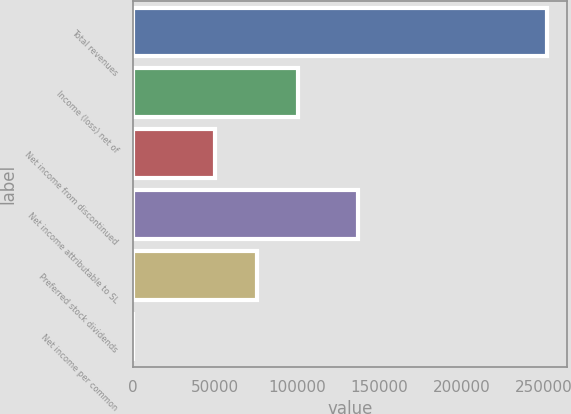Convert chart. <chart><loc_0><loc_0><loc_500><loc_500><bar_chart><fcel>Total revenues<fcel>Income (loss) net of<fcel>Net income from discontinued<fcel>Net income attributable to SL<fcel>Preferred stock dividends<fcel>Net income per common<nl><fcel>251684<fcel>100675<fcel>50338.2<fcel>137038<fcel>75506.4<fcel>1.75<nl></chart> 